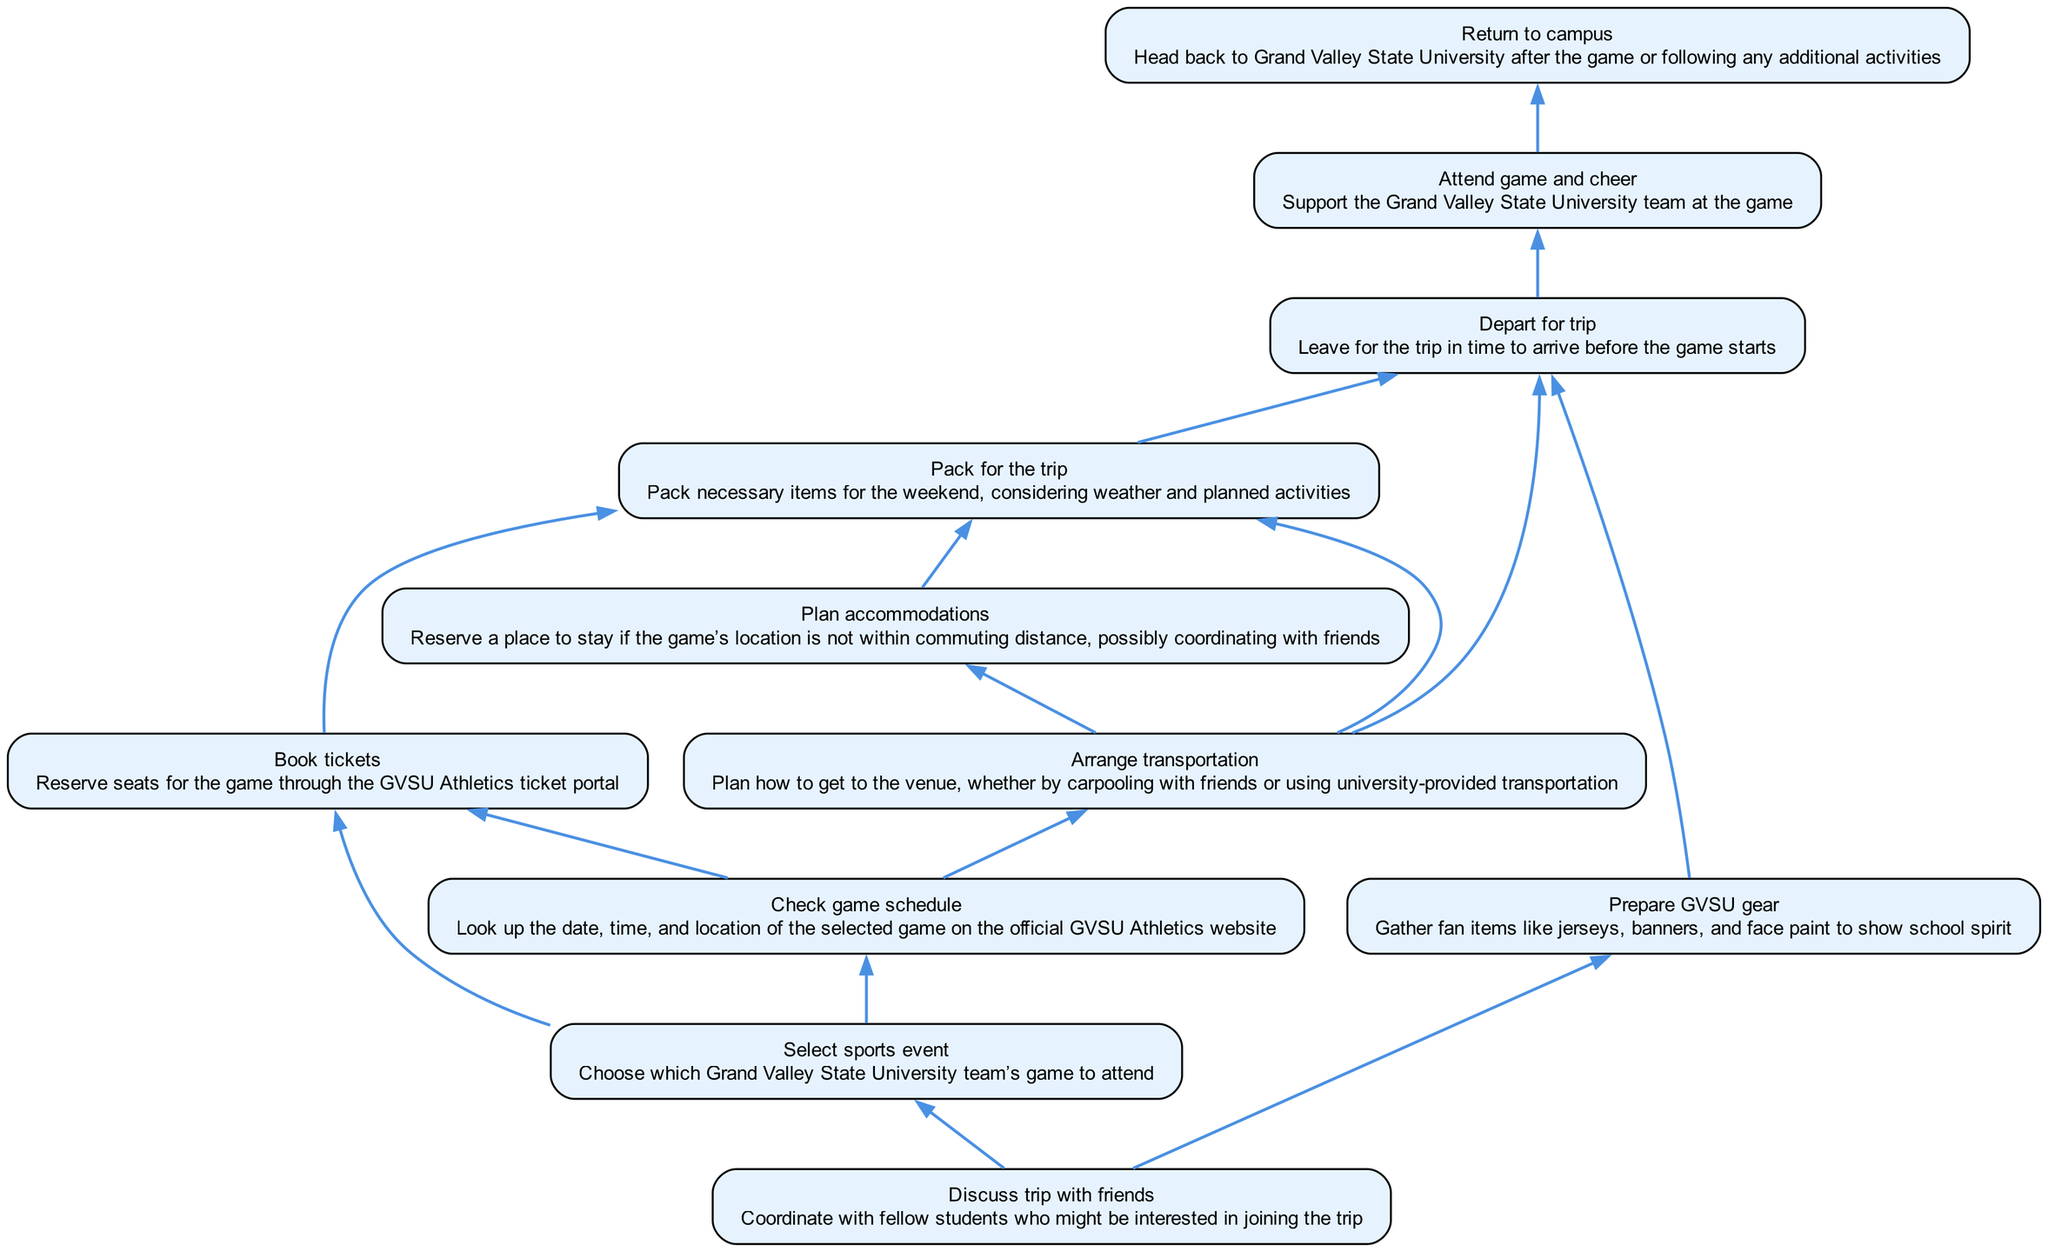What is the first step in planning a weekend trip? The first step in the flow chart is "Discuss trip with friends", which has no dependencies and initiates the planning process.
Answer: Discuss trip with friends How many total nodes are there in the diagram? By counting each step in the flow chart, there are a total of 10 nodes that represent different activities involved in planning the trip.
Answer: 10 Which step must be completed before booking tickets? The step "Check game schedule" must be completed before "Book tickets" as shown in the diagram, reflecting the dependency relationship.
Answer: Check game schedule What do you need to pack for the trip? The step "Pack for the trip" indicates that necessary items should be packed based on the tickets booked, transportation arranged, and accommodations planned.
Answer: Pack for the trip What are the final two activities in the trip planning process? The last two activities shown in the diagram are "Attend game and cheer" and "Return to campus", which follow the flow of the weekend trip.
Answer: Attend game and cheer, Return to campus Which activity directly depends on arranging transportation? The activity "Plan accommodations" directly depends on "Arrange transportation", as indicated by the directed edge in the flow chart connecting those two nodes.
Answer: Plan accommodations What needs to happen before departing for the trip? According to the flow chart, "Pack for the trip", "Prepare GVSU gear", and "Arrange transportation" must all be completed before "Depart for trip".
Answer: Pack for the trip, Prepare GVSU gear, Arrange transportation Which step optimally follows "Select sports event"? The optimal sequence following "Select sports event" is to "Check game schedule", highlighting the importance of determining game specifics after selecting the event.
Answer: Check game schedule How many dependencies does "Book tickets" have? "Book tickets" has two dependencies: "Select sports event" and "Check game schedule", indicating that both steps must be completed first.
Answer: 2 